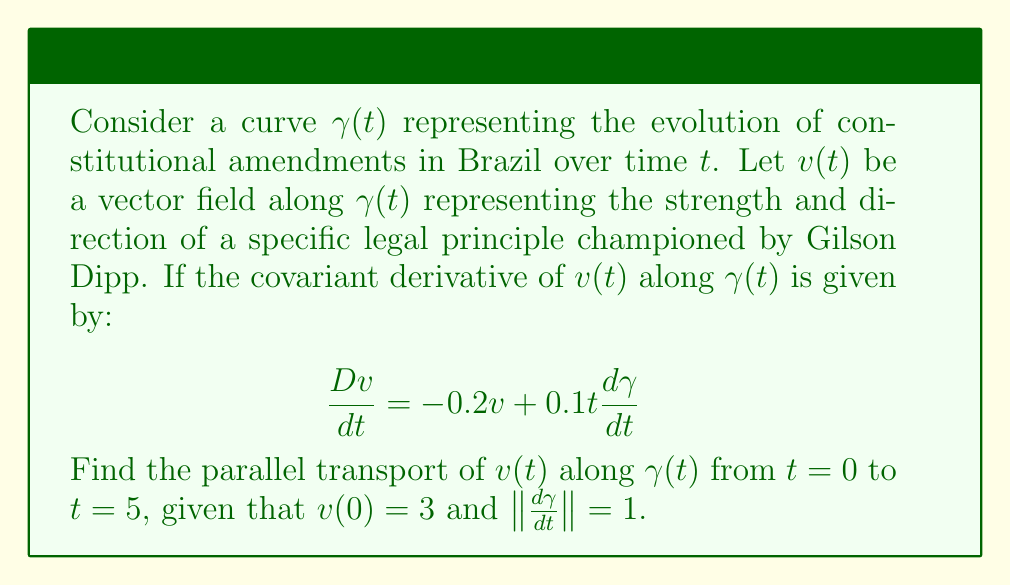Show me your answer to this math problem. To solve this problem, we need to follow these steps:

1) Recall that parallel transport requires the covariant derivative to be zero. So, we need to solve:

   $$\frac{Dv}{dt} = 0 = -0.2v + 0.1t\frac{d\gamma}{dt}$$

2) Rearranging the equation:

   $$0.2v = 0.1t\frac{d\gamma}{dt}$$

3) Given that $\|\frac{d\gamma}{dt}\| = 1$, we can simplify:

   $$0.2v = 0.1t$$

4) Solving for $v$:

   $$v = 0.5t$$

5) This gives us the general solution. To find the specific solution, we use the initial condition $v(0) = 3$:

   $$v(t) = 0.5t + 3$$

6) To find the parallel transport at $t=5$, we evaluate $v(5)$:

   $$v(5) = 0.5(5) + 3 = 5.5$$

Therefore, the parallel transport of the legal principle from $t=0$ to $t=5$ results in a strength of 5.5.
Answer: $v(5) = 5.5$ 